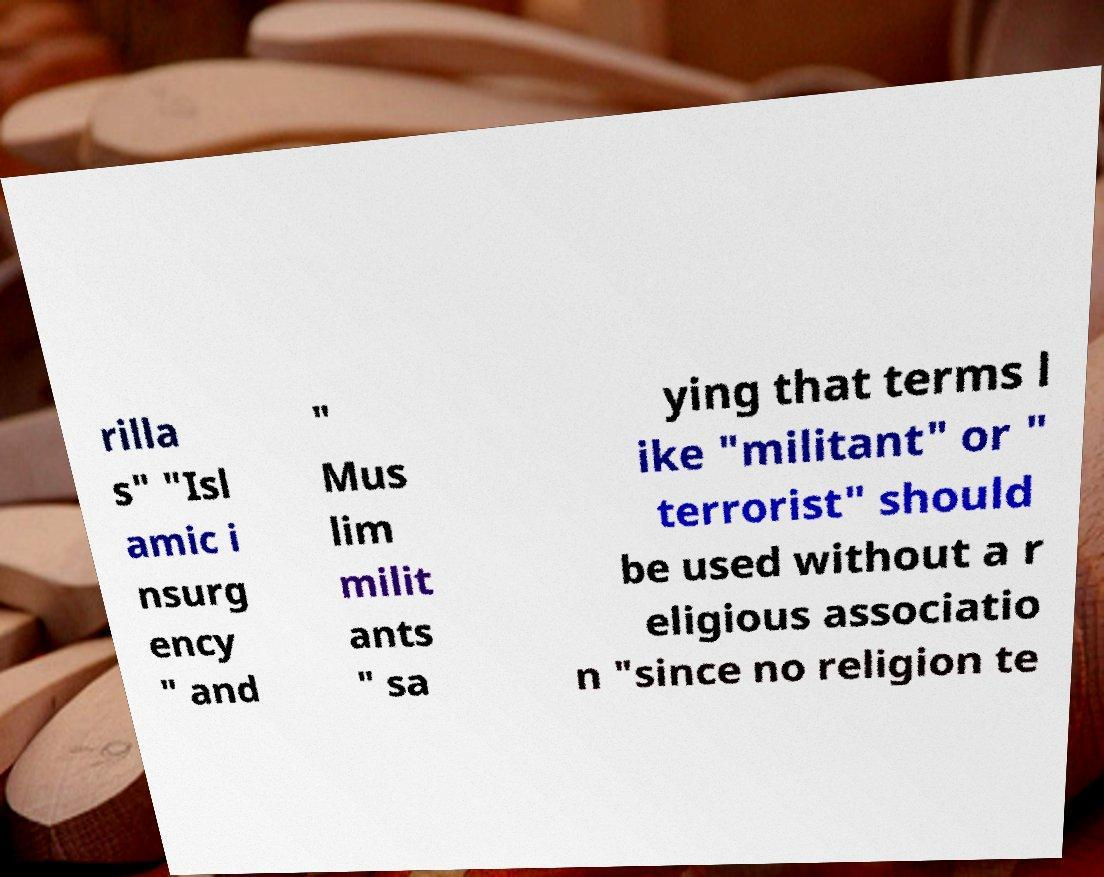Can you read and provide the text displayed in the image?This photo seems to have some interesting text. Can you extract and type it out for me? rilla s" "Isl amic i nsurg ency " and " Mus lim milit ants " sa ying that terms l ike "militant" or " terrorist" should be used without a r eligious associatio n "since no religion te 